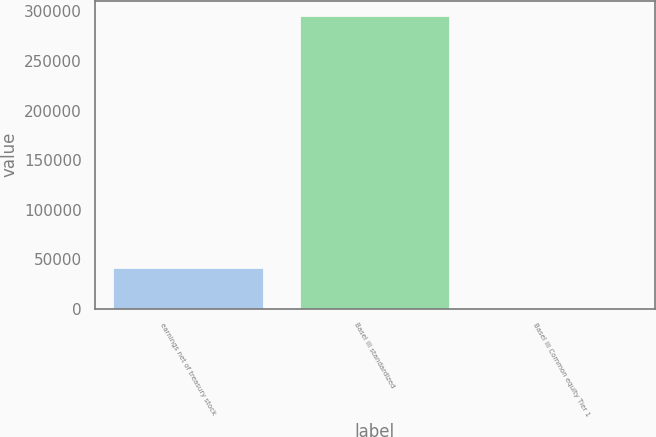<chart> <loc_0><loc_0><loc_500><loc_500><bar_chart><fcel>earnings net of treasury stock<fcel>Basel III standardized<fcel>Basel III Common equity Tier 1<nl><fcel>41128<fcel>295905<fcel>10.6<nl></chart> 